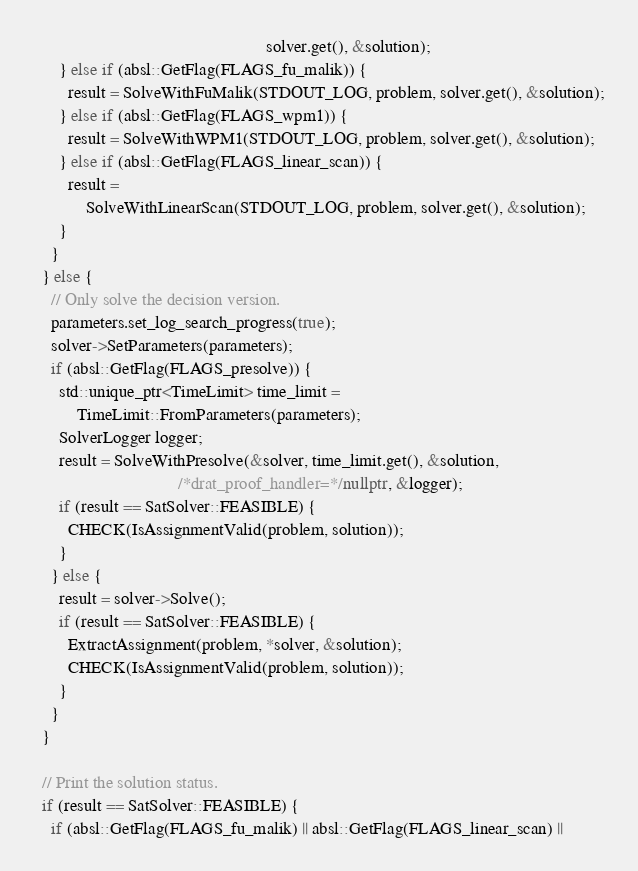<code> <loc_0><loc_0><loc_500><loc_500><_C++_>                                                     solver.get(), &solution);
      } else if (absl::GetFlag(FLAGS_fu_malik)) {
        result = SolveWithFuMalik(STDOUT_LOG, problem, solver.get(), &solution);
      } else if (absl::GetFlag(FLAGS_wpm1)) {
        result = SolveWithWPM1(STDOUT_LOG, problem, solver.get(), &solution);
      } else if (absl::GetFlag(FLAGS_linear_scan)) {
        result =
            SolveWithLinearScan(STDOUT_LOG, problem, solver.get(), &solution);
      }
    }
  } else {
    // Only solve the decision version.
    parameters.set_log_search_progress(true);
    solver->SetParameters(parameters);
    if (absl::GetFlag(FLAGS_presolve)) {
      std::unique_ptr<TimeLimit> time_limit =
          TimeLimit::FromParameters(parameters);
      SolverLogger logger;
      result = SolveWithPresolve(&solver, time_limit.get(), &solution,
                                 /*drat_proof_handler=*/nullptr, &logger);
      if (result == SatSolver::FEASIBLE) {
        CHECK(IsAssignmentValid(problem, solution));
      }
    } else {
      result = solver->Solve();
      if (result == SatSolver::FEASIBLE) {
        ExtractAssignment(problem, *solver, &solution);
        CHECK(IsAssignmentValid(problem, solution));
      }
    }
  }

  // Print the solution status.
  if (result == SatSolver::FEASIBLE) {
    if (absl::GetFlag(FLAGS_fu_malik) || absl::GetFlag(FLAGS_linear_scan) ||</code> 